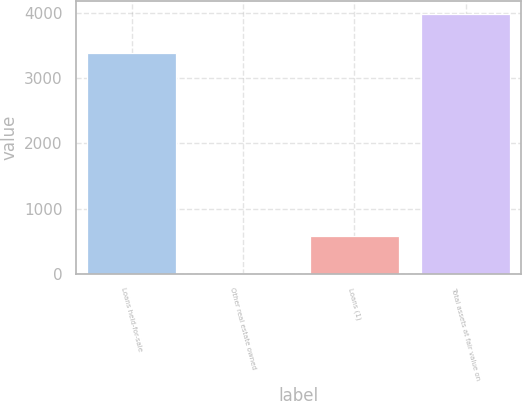Convert chart. <chart><loc_0><loc_0><loc_500><loc_500><bar_chart><fcel>Loans held-for-sale<fcel>Other real estate owned<fcel>Loans (1)<fcel>Total assets at fair value on<nl><fcel>3389<fcel>15<fcel>586<fcel>3990<nl></chart> 